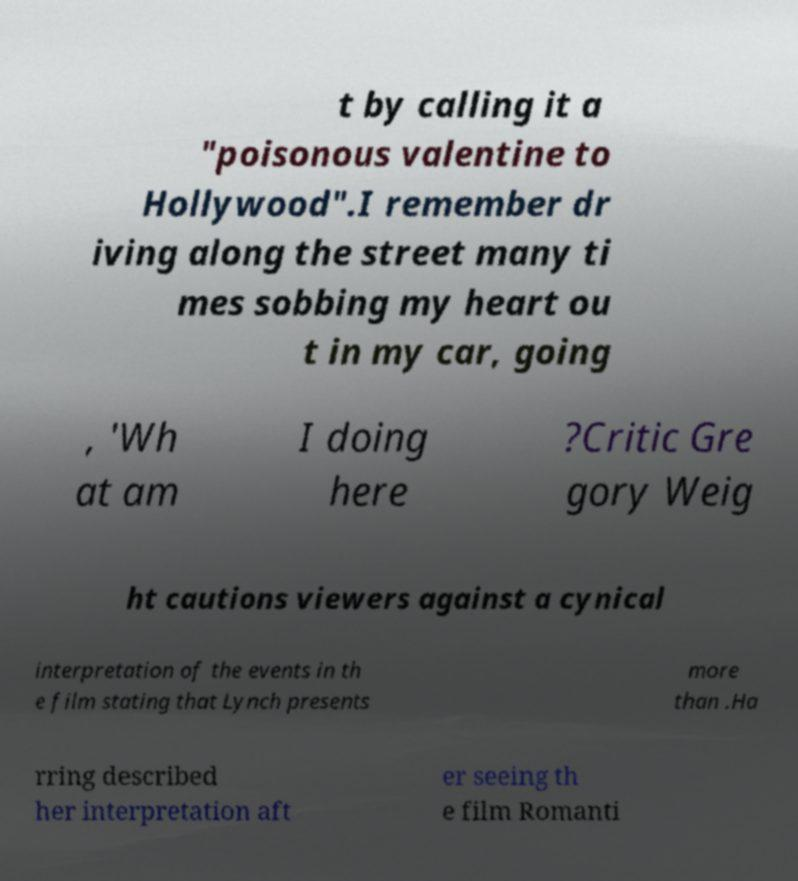Can you accurately transcribe the text from the provided image for me? t by calling it a "poisonous valentine to Hollywood".I remember dr iving along the street many ti mes sobbing my heart ou t in my car, going , 'Wh at am I doing here ?Critic Gre gory Weig ht cautions viewers against a cynical interpretation of the events in th e film stating that Lynch presents more than .Ha rring described her interpretation aft er seeing th e film Romanti 